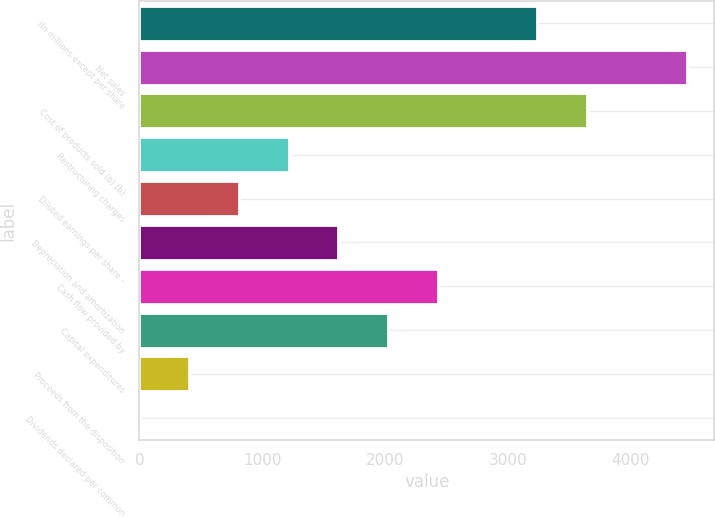Convert chart to OTSL. <chart><loc_0><loc_0><loc_500><loc_500><bar_chart><fcel>(In millions except per share<fcel>Net sales<fcel>Cost of products sold (b) (b)<fcel>Restructuring charges<fcel>Diluted earnings per share -<fcel>Depreciation and amortization<fcel>Cash flow provided by<fcel>Capital expenditures<fcel>Proceeds from the disposition<fcel>Dividends declared per common<nl><fcel>3241.3<fcel>4456.6<fcel>3646.4<fcel>1215.8<fcel>810.7<fcel>1620.9<fcel>2431.1<fcel>2026<fcel>405.6<fcel>0.5<nl></chart> 